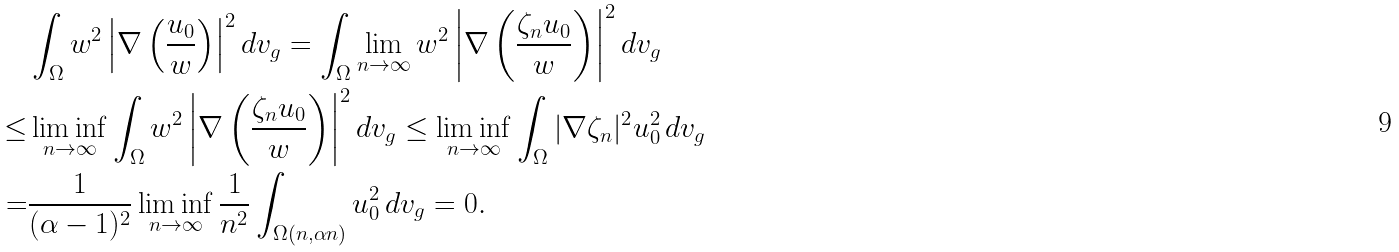<formula> <loc_0><loc_0><loc_500><loc_500>& \int _ { \Omega } w ^ { 2 } \left | \nabla \left ( \frac { u _ { 0 } } { w } \right ) \right | ^ { 2 } d v _ { g } = \int _ { \Omega } \lim _ { n \to \infty } w ^ { 2 } \left | \nabla \left ( \frac { \zeta _ { n } u _ { 0 } } { w } \right ) \right | ^ { 2 } d v _ { g } \\ \leq & \liminf _ { n \to \infty } \int _ { \Omega } w ^ { 2 } \left | \nabla \left ( \frac { \zeta _ { n } u _ { 0 } } { w } \right ) \right | ^ { 2 } d v _ { g } \leq \liminf _ { n \to \infty } \int _ { \Omega } | \nabla \zeta _ { n } | ^ { 2 } u _ { 0 } ^ { 2 } \, d v _ { g } \\ = & \frac { 1 } { ( \alpha - 1 ) ^ { 2 } } \liminf _ { n \to \infty } \frac { 1 } { n ^ { 2 } } \int _ { \Omega ( n , \alpha n ) } u _ { 0 } ^ { 2 } \, d v _ { g } = 0 .</formula> 